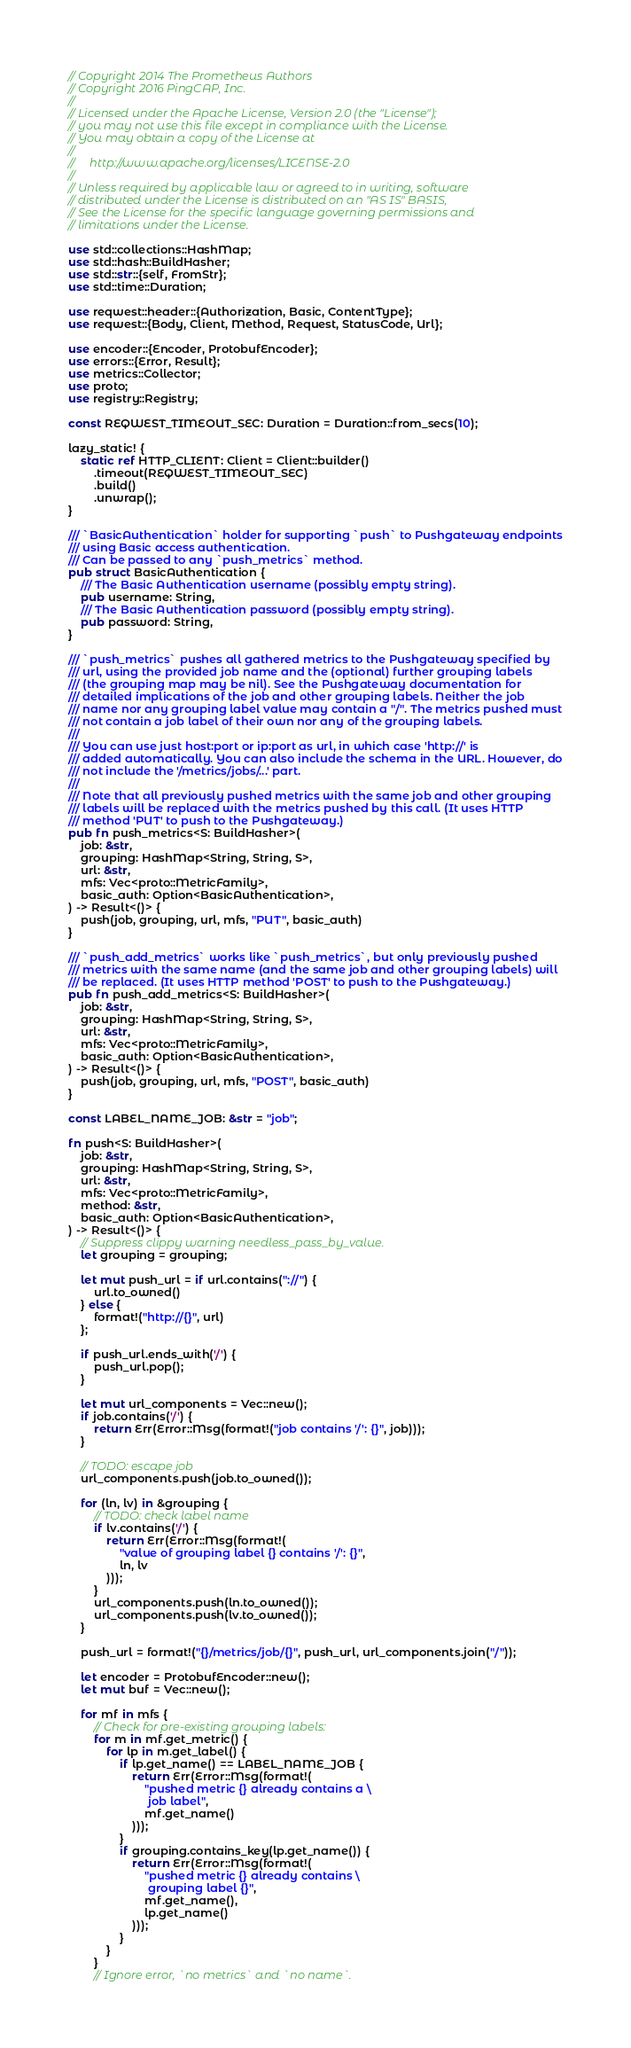<code> <loc_0><loc_0><loc_500><loc_500><_Rust_>// Copyright 2014 The Prometheus Authors
// Copyright 2016 PingCAP, Inc.
//
// Licensed under the Apache License, Version 2.0 (the "License");
// you may not use this file except in compliance with the License.
// You may obtain a copy of the License at
//
//     http://www.apache.org/licenses/LICENSE-2.0
//
// Unless required by applicable law or agreed to in writing, software
// distributed under the License is distributed on an "AS IS" BASIS,
// See the License for the specific language governing permissions and
// limitations under the License.

use std::collections::HashMap;
use std::hash::BuildHasher;
use std::str::{self, FromStr};
use std::time::Duration;

use reqwest::header::{Authorization, Basic, ContentType};
use reqwest::{Body, Client, Method, Request, StatusCode, Url};

use encoder::{Encoder, ProtobufEncoder};
use errors::{Error, Result};
use metrics::Collector;
use proto;
use registry::Registry;

const REQWEST_TIMEOUT_SEC: Duration = Duration::from_secs(10);

lazy_static! {
    static ref HTTP_CLIENT: Client = Client::builder()
        .timeout(REQWEST_TIMEOUT_SEC)
        .build()
        .unwrap();
}

/// `BasicAuthentication` holder for supporting `push` to Pushgateway endpoints
/// using Basic access authentication.
/// Can be passed to any `push_metrics` method.
pub struct BasicAuthentication {
    /// The Basic Authentication username (possibly empty string).
    pub username: String,
    /// The Basic Authentication password (possibly empty string).
    pub password: String,
}

/// `push_metrics` pushes all gathered metrics to the Pushgateway specified by
/// url, using the provided job name and the (optional) further grouping labels
/// (the grouping map may be nil). See the Pushgateway documentation for
/// detailed implications of the job and other grouping labels. Neither the job
/// name nor any grouping label value may contain a "/". The metrics pushed must
/// not contain a job label of their own nor any of the grouping labels.
///
/// You can use just host:port or ip:port as url, in which case 'http://' is
/// added automatically. You can also include the schema in the URL. However, do
/// not include the '/metrics/jobs/...' part.
///
/// Note that all previously pushed metrics with the same job and other grouping
/// labels will be replaced with the metrics pushed by this call. (It uses HTTP
/// method 'PUT' to push to the Pushgateway.)
pub fn push_metrics<S: BuildHasher>(
    job: &str,
    grouping: HashMap<String, String, S>,
    url: &str,
    mfs: Vec<proto::MetricFamily>,
    basic_auth: Option<BasicAuthentication>,
) -> Result<()> {
    push(job, grouping, url, mfs, "PUT", basic_auth)
}

/// `push_add_metrics` works like `push_metrics`, but only previously pushed
/// metrics with the same name (and the same job and other grouping labels) will
/// be replaced. (It uses HTTP method 'POST' to push to the Pushgateway.)
pub fn push_add_metrics<S: BuildHasher>(
    job: &str,
    grouping: HashMap<String, String, S>,
    url: &str,
    mfs: Vec<proto::MetricFamily>,
    basic_auth: Option<BasicAuthentication>,
) -> Result<()> {
    push(job, grouping, url, mfs, "POST", basic_auth)
}

const LABEL_NAME_JOB: &str = "job";

fn push<S: BuildHasher>(
    job: &str,
    grouping: HashMap<String, String, S>,
    url: &str,
    mfs: Vec<proto::MetricFamily>,
    method: &str,
    basic_auth: Option<BasicAuthentication>,
) -> Result<()> {
    // Suppress clippy warning needless_pass_by_value.
    let grouping = grouping;

    let mut push_url = if url.contains("://") {
        url.to_owned()
    } else {
        format!("http://{}", url)
    };

    if push_url.ends_with('/') {
        push_url.pop();
    }

    let mut url_components = Vec::new();
    if job.contains('/') {
        return Err(Error::Msg(format!("job contains '/': {}", job)));
    }

    // TODO: escape job
    url_components.push(job.to_owned());

    for (ln, lv) in &grouping {
        // TODO: check label name
        if lv.contains('/') {
            return Err(Error::Msg(format!(
                "value of grouping label {} contains '/': {}",
                ln, lv
            )));
        }
        url_components.push(ln.to_owned());
        url_components.push(lv.to_owned());
    }

    push_url = format!("{}/metrics/job/{}", push_url, url_components.join("/"));

    let encoder = ProtobufEncoder::new();
    let mut buf = Vec::new();

    for mf in mfs {
        // Check for pre-existing grouping labels:
        for m in mf.get_metric() {
            for lp in m.get_label() {
                if lp.get_name() == LABEL_NAME_JOB {
                    return Err(Error::Msg(format!(
                        "pushed metric {} already contains a \
                         job label",
                        mf.get_name()
                    )));
                }
                if grouping.contains_key(lp.get_name()) {
                    return Err(Error::Msg(format!(
                        "pushed metric {} already contains \
                         grouping label {}",
                        mf.get_name(),
                        lp.get_name()
                    )));
                }
            }
        }
        // Ignore error, `no metrics` and `no name`.</code> 